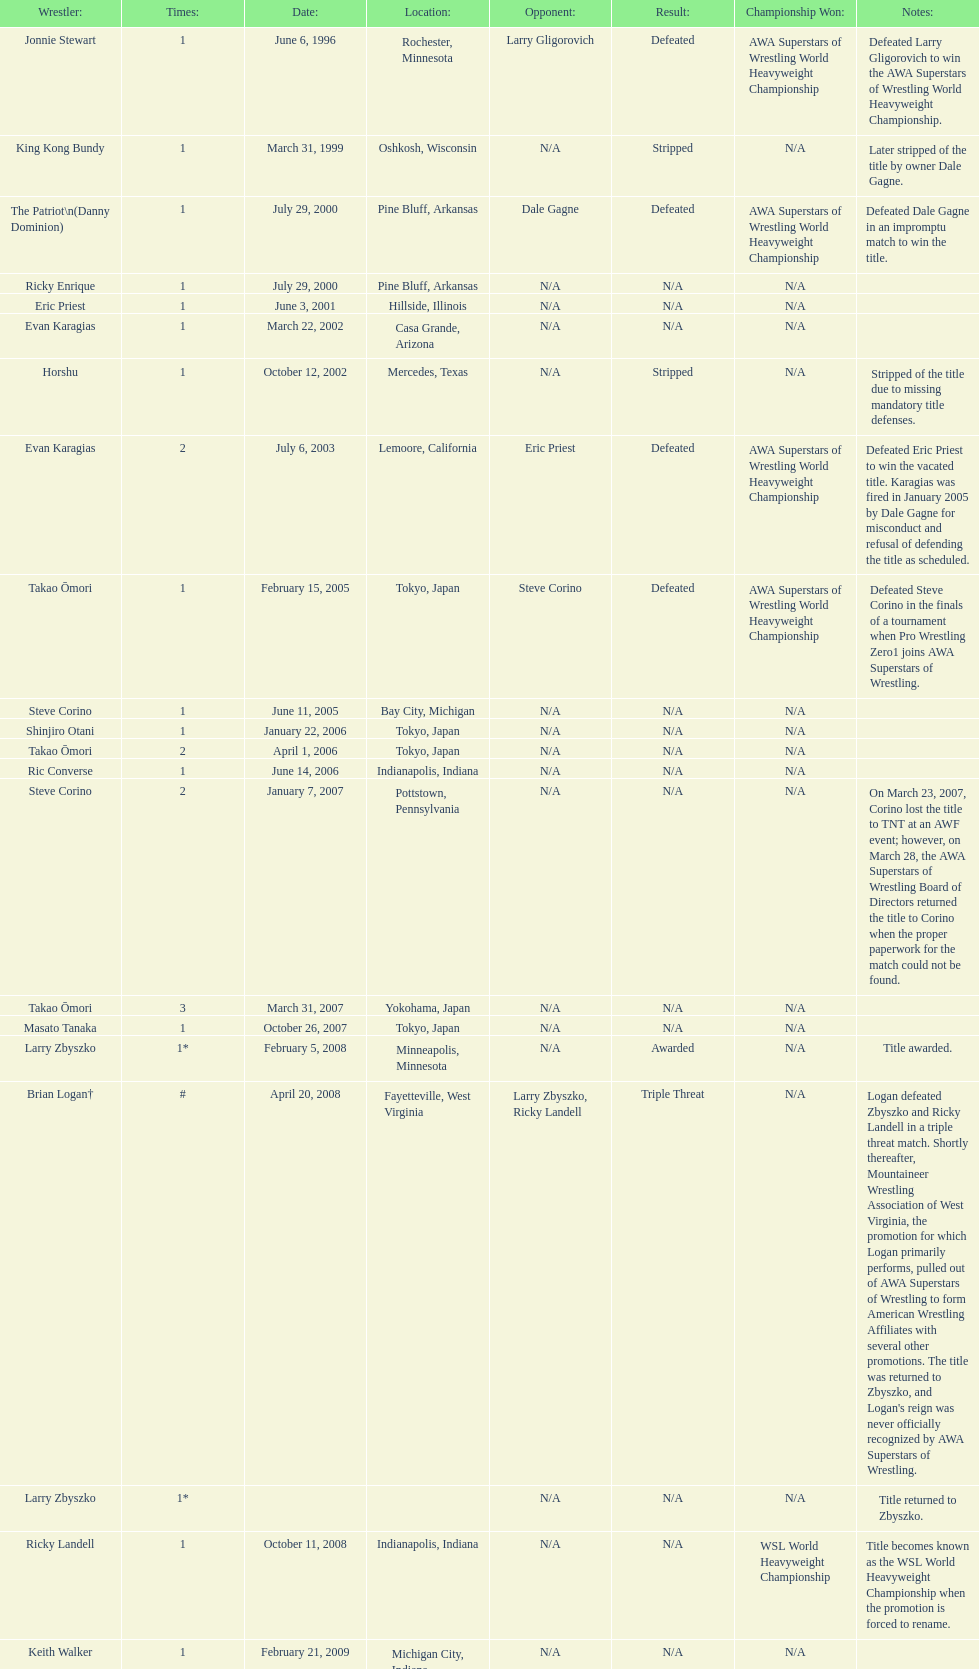What are the number of matches that happened in japan? 5. 